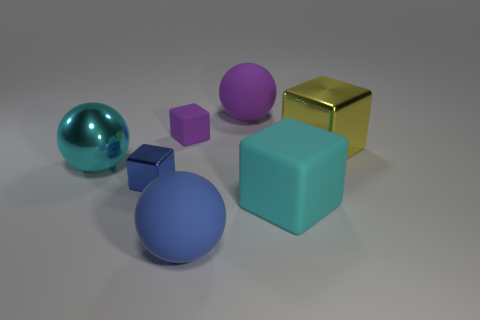Subtract all green balls. Subtract all cyan blocks. How many balls are left? 3 Add 2 purple matte things. How many objects exist? 9 Subtract all balls. How many objects are left? 4 Add 1 big cyan metal things. How many big cyan metal things exist? 2 Subtract 0 yellow spheres. How many objects are left? 7 Subtract all large objects. Subtract all blue matte objects. How many objects are left? 1 Add 1 tiny blue metal objects. How many tiny blue metal objects are left? 2 